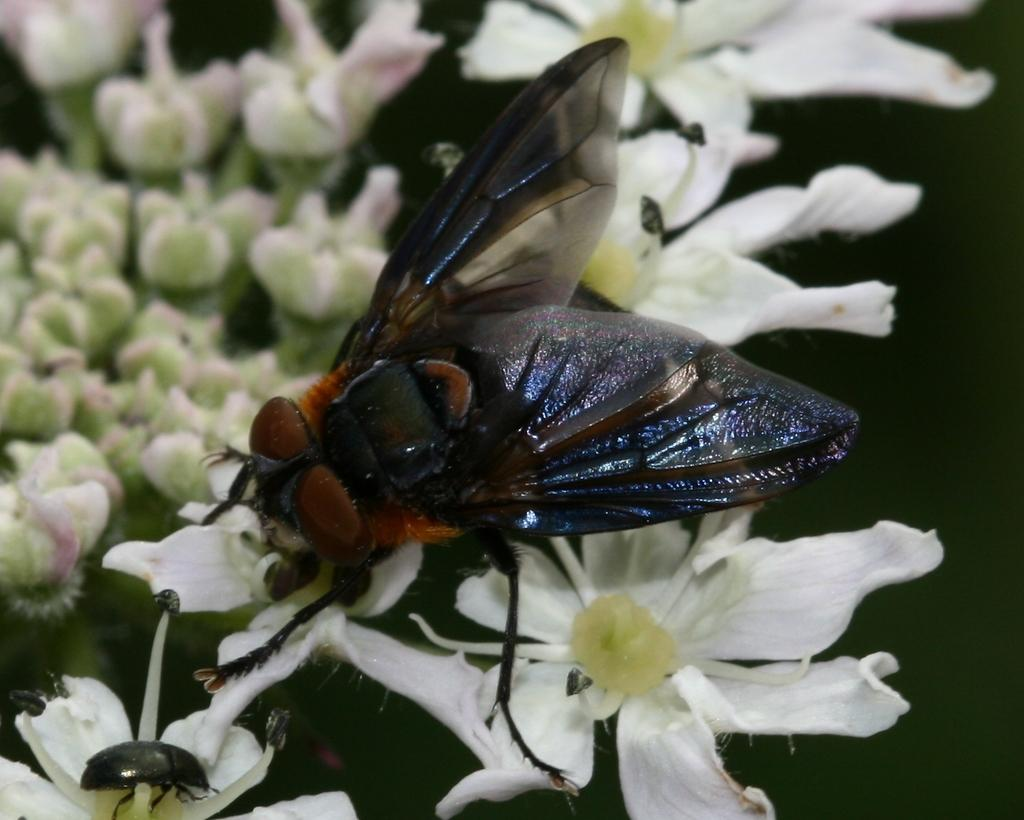What is located in the center of the image? There is a fly in the center of the image. What type of vegetation is present at the bottom of the image? There are flowers and buds at the bottom of the image. What type of stone can be seen supporting the roots of the flowers in the image? There is no stone or roots of flowers present in the image; it only features a fly and flowers and buds. 